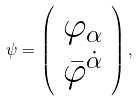Convert formula to latex. <formula><loc_0><loc_0><loc_500><loc_500>\psi = \left ( \begin{array} { c } \varphi _ { \alpha } \\ \bar { \varphi } ^ { \dot { \alpha } } \end{array} \right ) ,</formula> 